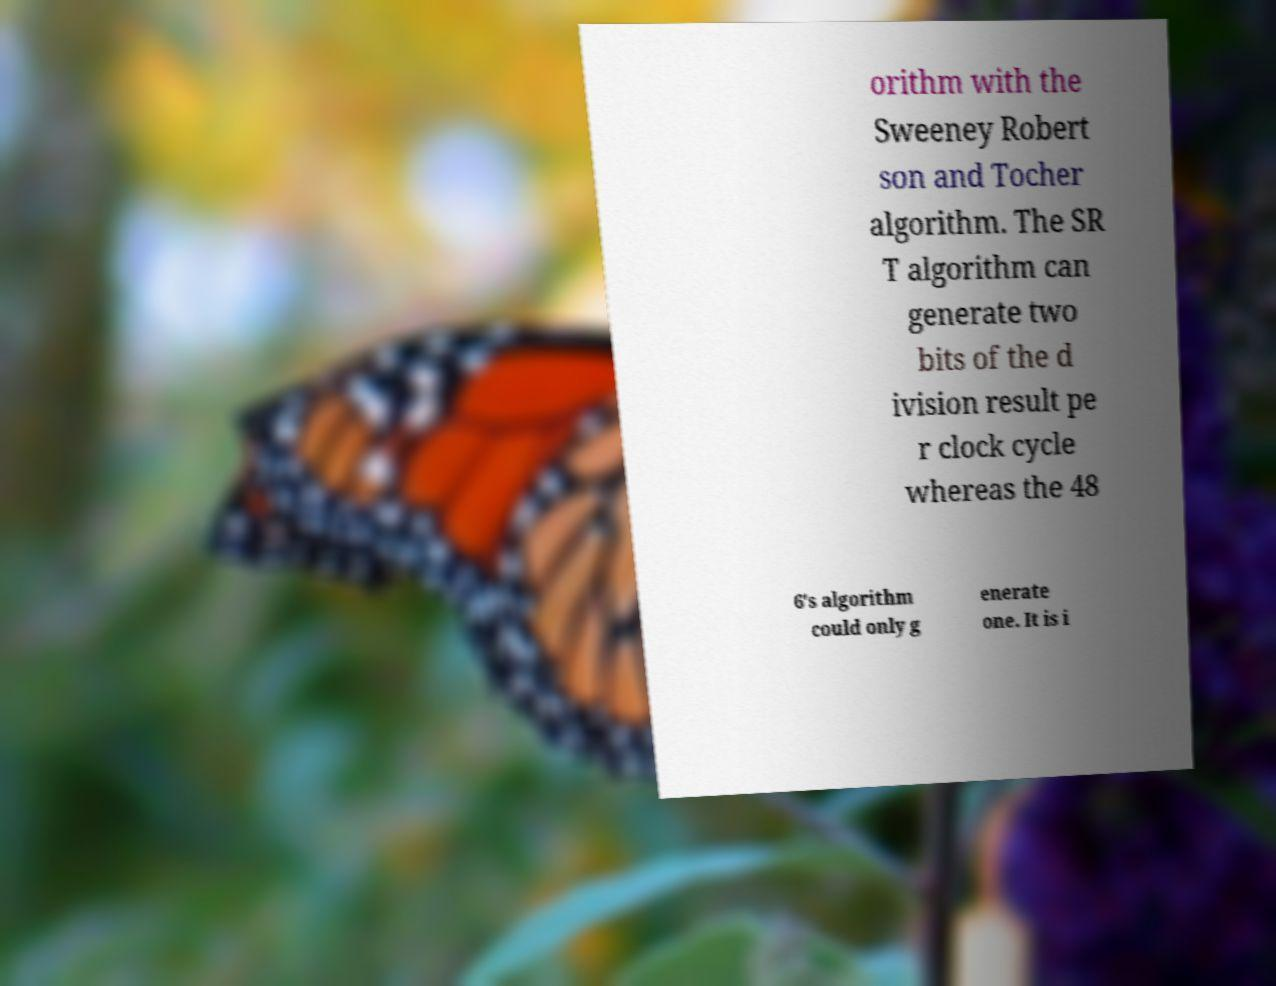For documentation purposes, I need the text within this image transcribed. Could you provide that? orithm with the Sweeney Robert son and Tocher algorithm. The SR T algorithm can generate two bits of the d ivision result pe r clock cycle whereas the 48 6's algorithm could only g enerate one. It is i 